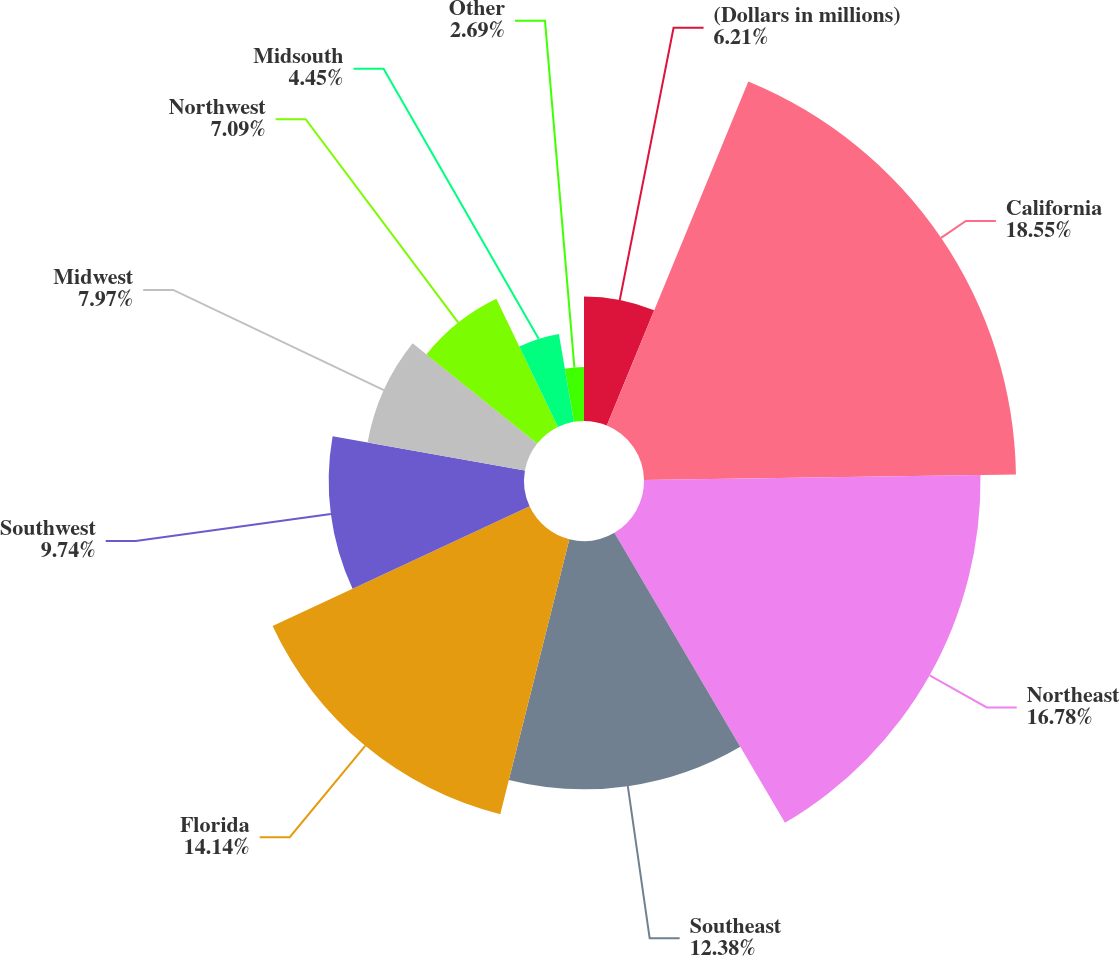<chart> <loc_0><loc_0><loc_500><loc_500><pie_chart><fcel>(Dollars in millions)<fcel>California<fcel>Northeast<fcel>Southeast<fcel>Florida<fcel>Southwest<fcel>Midwest<fcel>Northwest<fcel>Midsouth<fcel>Other<nl><fcel>6.21%<fcel>18.55%<fcel>16.78%<fcel>12.38%<fcel>14.14%<fcel>9.74%<fcel>7.97%<fcel>7.09%<fcel>4.45%<fcel>2.69%<nl></chart> 